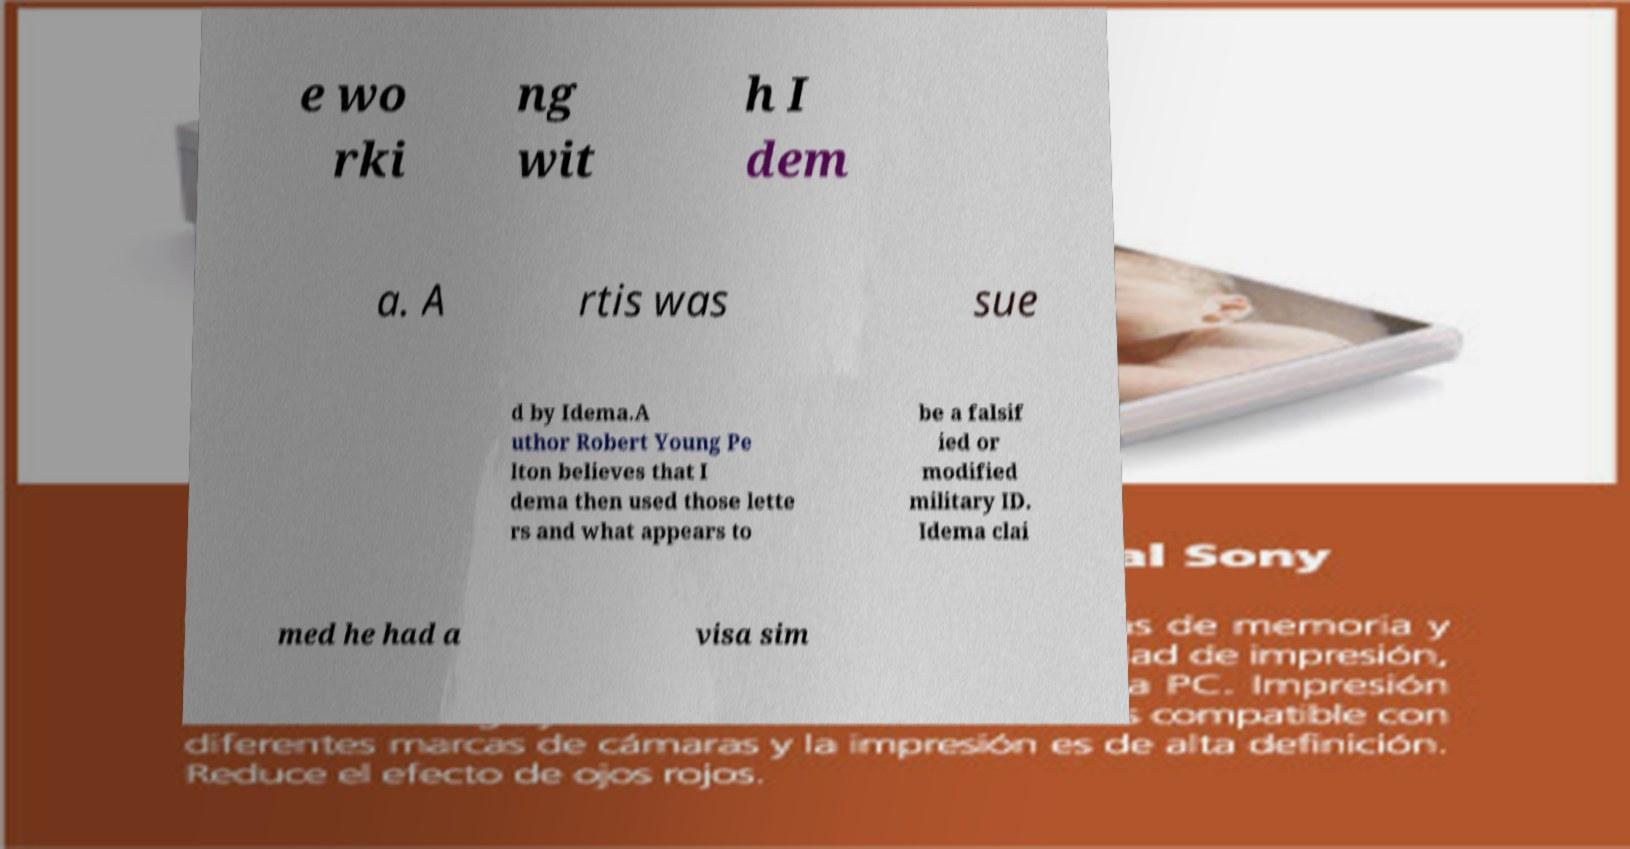Can you read and provide the text displayed in the image?This photo seems to have some interesting text. Can you extract and type it out for me? e wo rki ng wit h I dem a. A rtis was sue d by Idema.A uthor Robert Young Pe lton believes that I dema then used those lette rs and what appears to be a falsif ied or modified military ID. Idema clai med he had a visa sim 